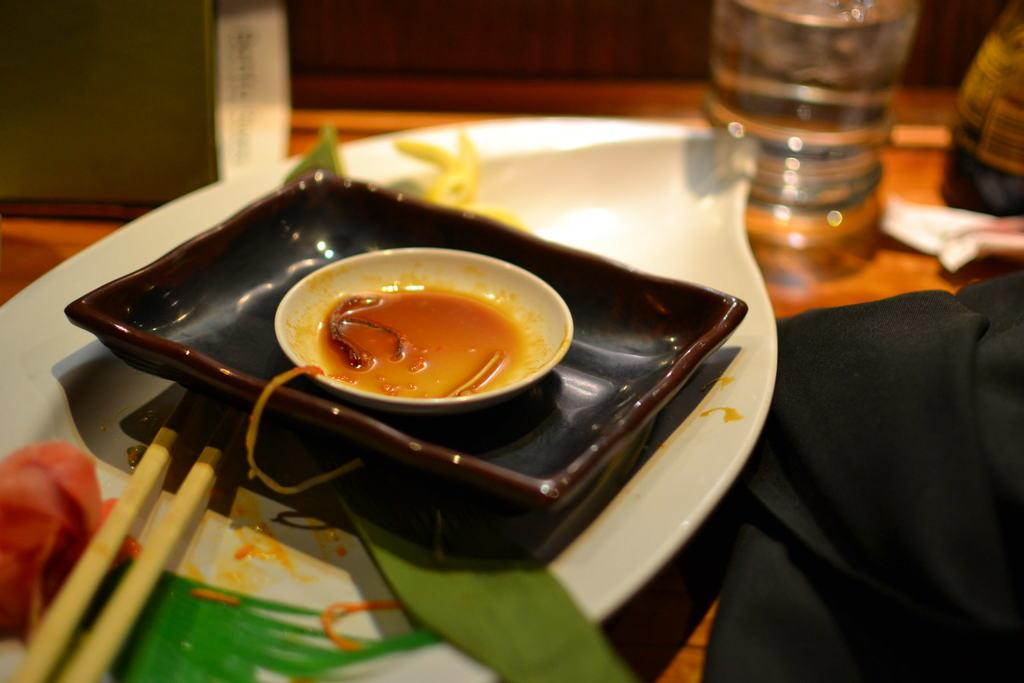How many plates are visible in the image? There are three plates in the image. What other objects can be seen on the table? There are two sticks and a bottle visible in the image. Where are all the objects located? All objects are on a table. Can you describe the zebra's journey in the image? There is no zebra present in the image, so it is not possible to describe its journey. 